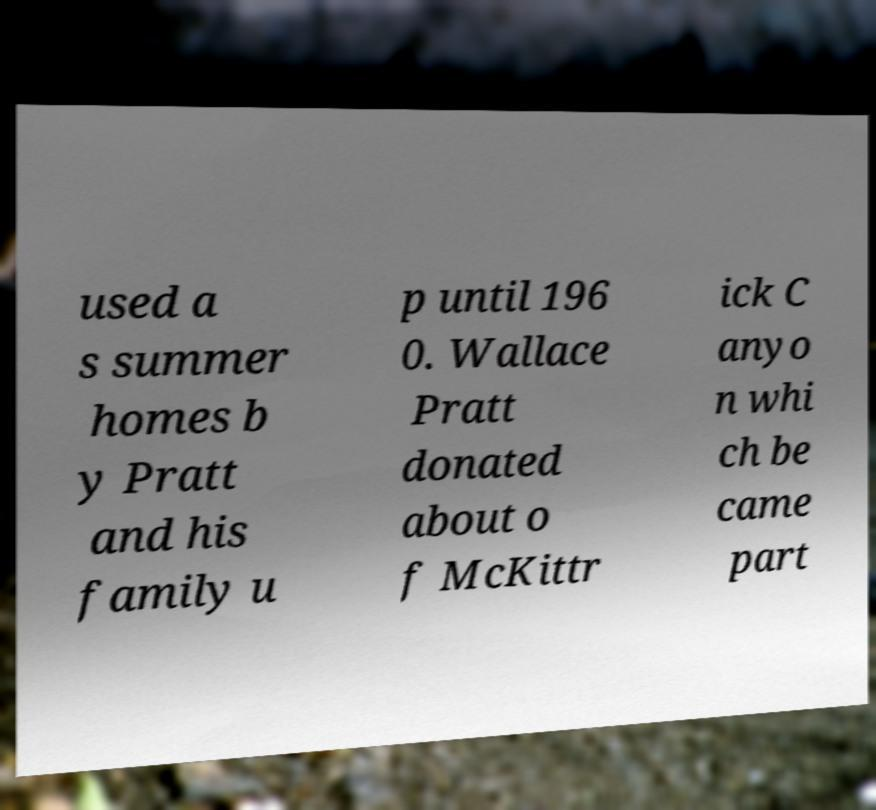Could you extract and type out the text from this image? used a s summer homes b y Pratt and his family u p until 196 0. Wallace Pratt donated about o f McKittr ick C anyo n whi ch be came part 